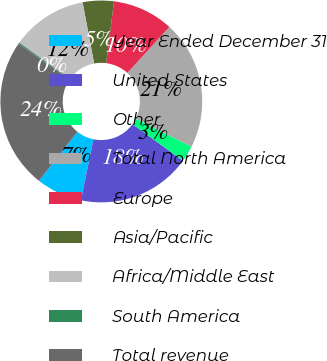Convert chart to OTSL. <chart><loc_0><loc_0><loc_500><loc_500><pie_chart><fcel>Year Ended December 31<fcel>United States<fcel>Other<fcel>Total North America<fcel>Europe<fcel>Asia/Pacific<fcel>Africa/Middle East<fcel>South America<fcel>Total revenue<nl><fcel>7.37%<fcel>18.24%<fcel>2.6%<fcel>20.62%<fcel>9.76%<fcel>4.99%<fcel>12.14%<fcel>0.21%<fcel>24.07%<nl></chart> 